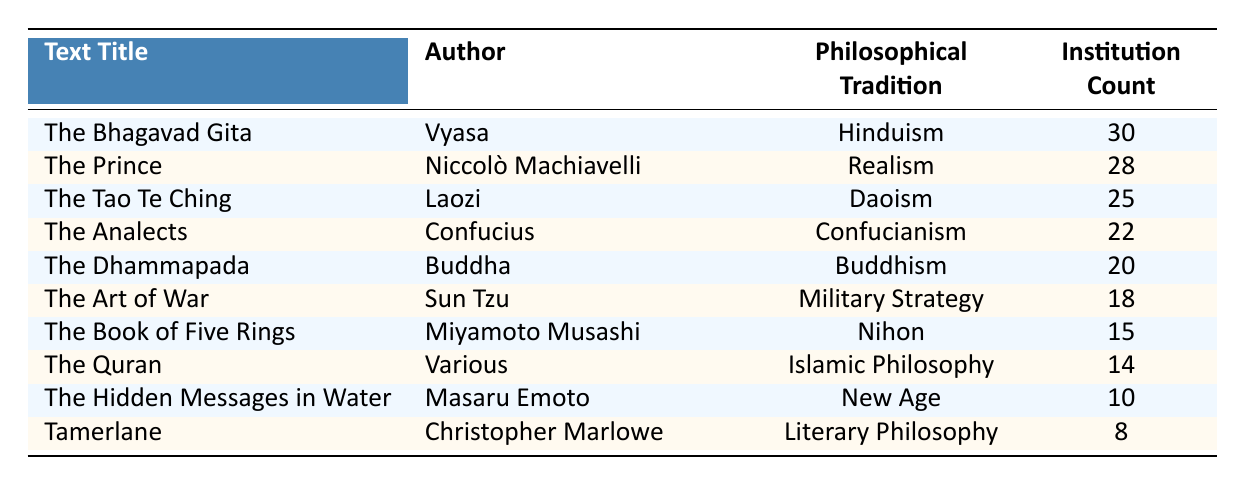What is the highest institution count among the texts listed? The highest institution count can be found by looking across the "Institution Count" column. The maximum is 30, associated with "The Bhagavad Gita" by Vyasa.
Answer: 30 Which philosophical tradition has the lowest representation in university curricula? To determine this, we compare the "Institution Count" for each philosophical tradition. "Tamerlane" by Christopher Marlowe from Literary Philosophy has the lowest count at 8.
Answer: Literary Philosophy What is the total institution count for texts belonging to Buddhism and Daoism? We need to find the institution counts for both texts: "The Dhammapada" (20) and "The Tao Te Ching" (25). Adding these together gives 20 + 25 = 45.
Answer: 45 Is there a text from the Islamic Philosophy tradition with an institution count greater than 10? Looking at "The Quran" in the Islamic Philosophy tradition, the institution count is 14, which is greater than 10.
Answer: Yes How many philosophical traditions have an institution count of 20 or more? The traditions with counts of 20 or more are: Hinduism (30), Realism (28), Daoism (25), Confucianism (22), and Buddhism (20). In total, there are five traditions that meet this criterion.
Answer: 5 Which text represents the Military Strategy tradition, and how many institutions teach it? "The Art of War" by Sun Tzu represents the Military Strategy tradition, and it is taught in 18 institutions.
Answer: The Art of War, 18 What is the difference in institution counts between "The Bhagavad Gita" and "The Art of War"? "The Bhagavad Gita" has an institution count of 30, while "The Art of War" has 18. The difference is 30 - 18 = 12.
Answer: 12 Which two texts have similar institution counts, where one is from Buddhism and one from Daoism? "The Dhammapada" from Buddhism has an institution count of 20, and "The Tao Te Ching" from Daoism has 25. They are close in count, but no texts from these traditions have the same count.
Answer: No similar counts What is the average number of institutions for the texts listed under New Age and Nihon philosophical traditions? The counts are: "The Hidden Messages in Water" (10) for New Age and "The Book of Five Rings" (15) for Nihon. Adding the counts gives 10 + 15 = 25. The average is 25 / 2 = 12.5.
Answer: 12.5 